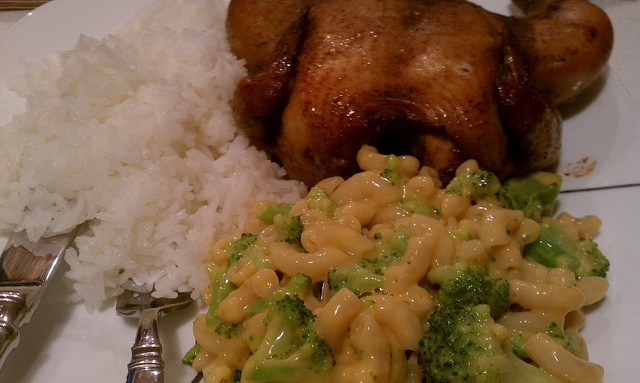Describe the objects in this image and their specific colors. I can see broccoli in maroon, olive, black, and darkgreen tones, broccoli in maroon, olive, and black tones, knife in maroon and gray tones, fork in maroon, black, and gray tones, and broccoli in maroon, olive, black, and darkgreen tones in this image. 